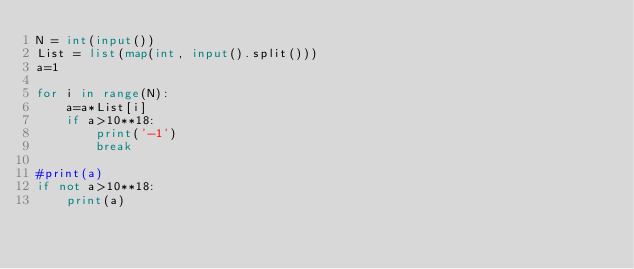Convert code to text. <code><loc_0><loc_0><loc_500><loc_500><_Python_>N = int(input())
List = list(map(int, input().split()))
a=1

for i in range(N):
    a=a*List[i]
    if a>10**18:
        print('-1')
        break
   
#print(a)
if not a>10**18:
    print(a)</code> 